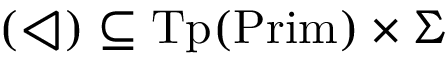Convert formula to latex. <formula><loc_0><loc_0><loc_500><loc_500>( \triangleleft ) \subseteq { T p } ( { P r i m } ) \times \Sigma</formula> 